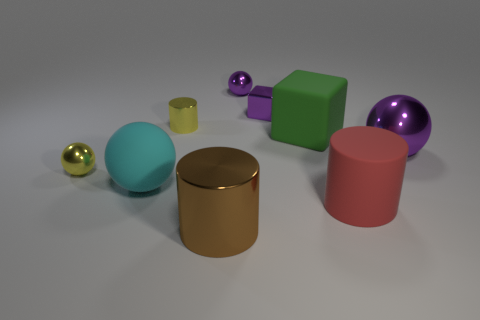What number of large red things are there?
Keep it short and to the point. 1. How many yellow objects are small shiny cylinders or big things?
Provide a short and direct response. 1. Does the large object behind the large purple sphere have the same material as the tiny purple block?
Provide a succinct answer. No. What number of other objects are the same material as the small cylinder?
Give a very brief answer. 5. What material is the big cyan sphere?
Your answer should be very brief. Rubber. What is the size of the matte block behind the small yellow ball?
Provide a succinct answer. Large. How many tiny metallic things are behind the purple metallic object that is right of the big red matte thing?
Offer a very short reply. 3. Do the tiny yellow shiny object that is behind the big purple metallic thing and the purple thing in front of the small cylinder have the same shape?
Give a very brief answer. No. How many metallic things are both to the left of the rubber cylinder and behind the brown shiny cylinder?
Your response must be concise. 4. Is there a shiny sphere of the same color as the tiny shiny cylinder?
Give a very brief answer. Yes. 